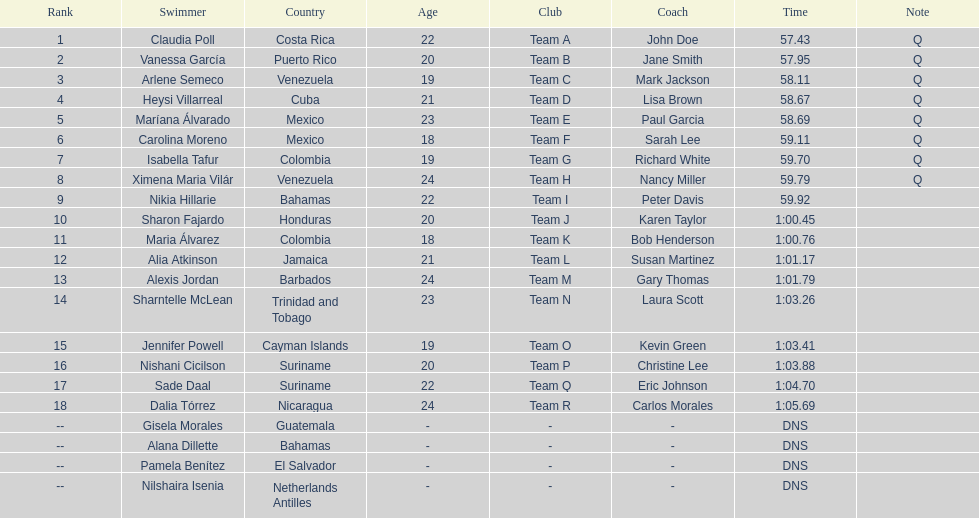Which swimmer had the longest time? Dalia Tórrez. 